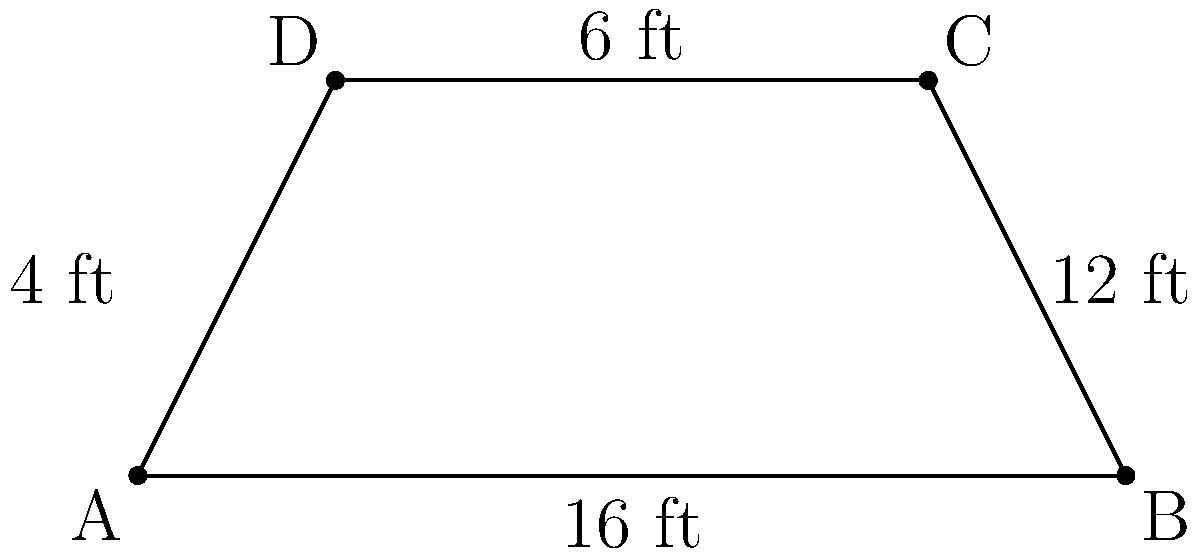Darci Lynne's upcoming family-friendly talent show is being advertised with a trapezoid-shaped banner. The banner's bottom edge measures 16 feet, the top edge is 6 feet, and the height is 4 feet. What is the area of the banner in square feet? To find the area of a trapezoid, we can use the formula:

$$ A = \frac{1}{2}(b_1 + b_2)h $$

Where:
$A$ = Area
$b_1$ = Length of one parallel side (bottom base)
$b_2$ = Length of the other parallel side (top base)
$h$ = Height (perpendicular distance between the parallel sides)

Given:
$b_1 = 16$ feet (bottom base)
$b_2 = 6$ feet (top base)
$h = 4$ feet (height)

Let's substitute these values into the formula:

$$ A = \frac{1}{2}(16 + 6) \times 4 $$

$$ A = \frac{1}{2}(22) \times 4 $$

$$ A = 11 \times 4 $$

$$ A = 44 $$

Therefore, the area of the trapezoid-shaped banner is 44 square feet.
Answer: 44 sq ft 